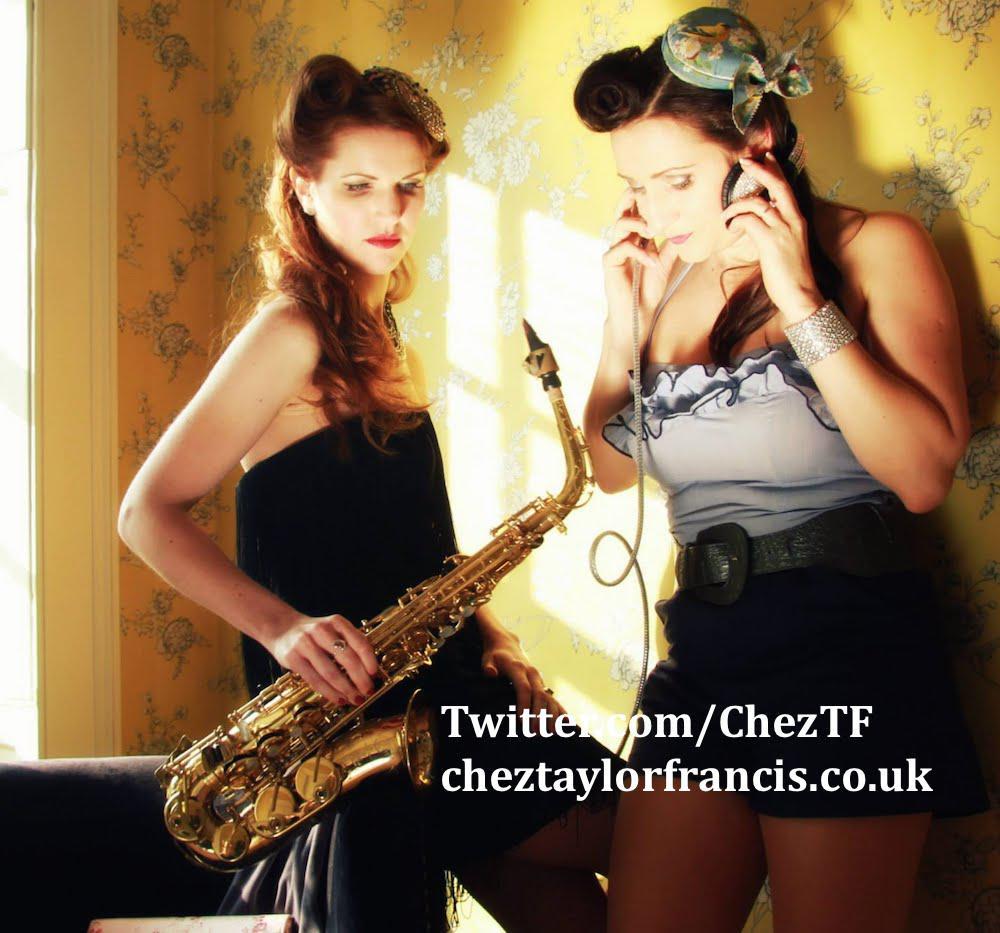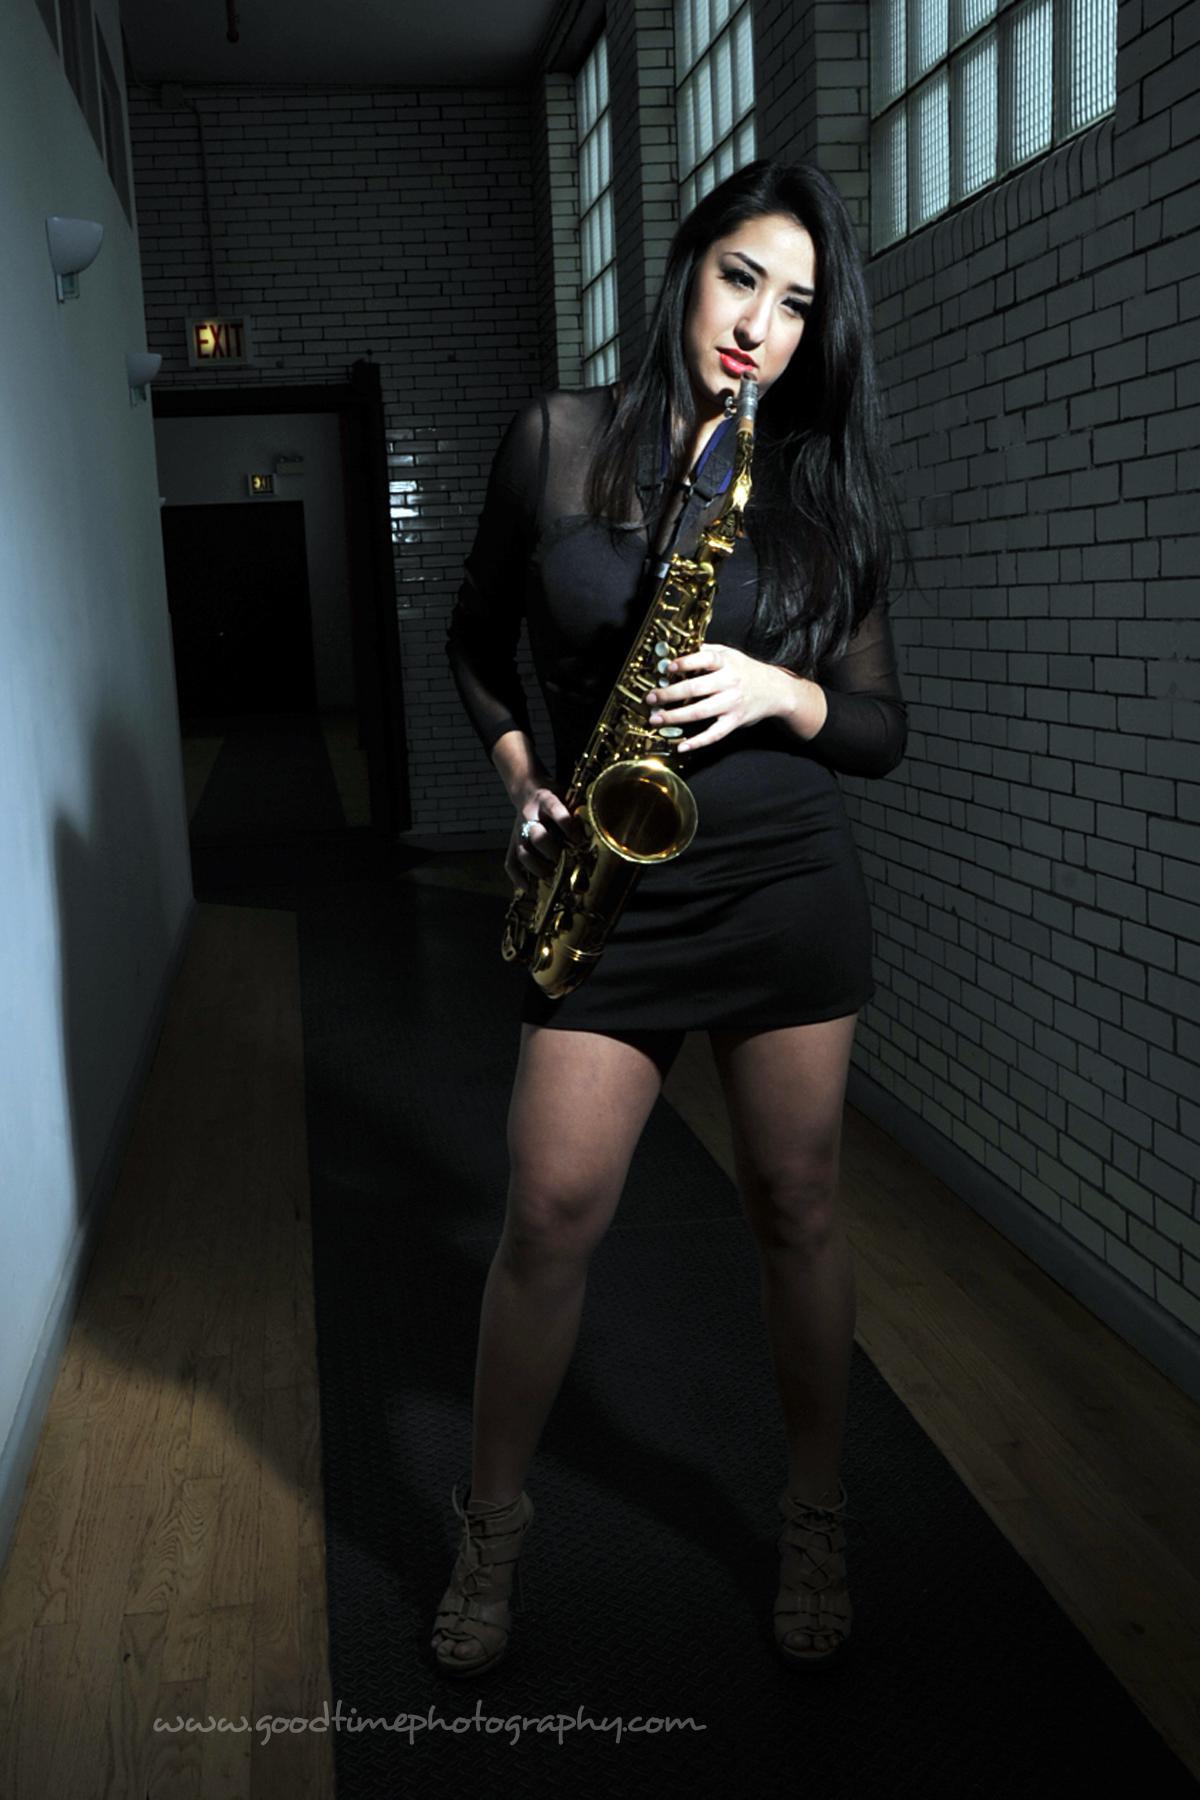The first image is the image on the left, the second image is the image on the right. Assess this claim about the two images: "The saxophone in each of the images is being played by a female child.". Correct or not? Answer yes or no. No. The first image is the image on the left, the second image is the image on the right. Considering the images on both sides, is "Each image shows a female child holding a saxophone." valid? Answer yes or no. No. 